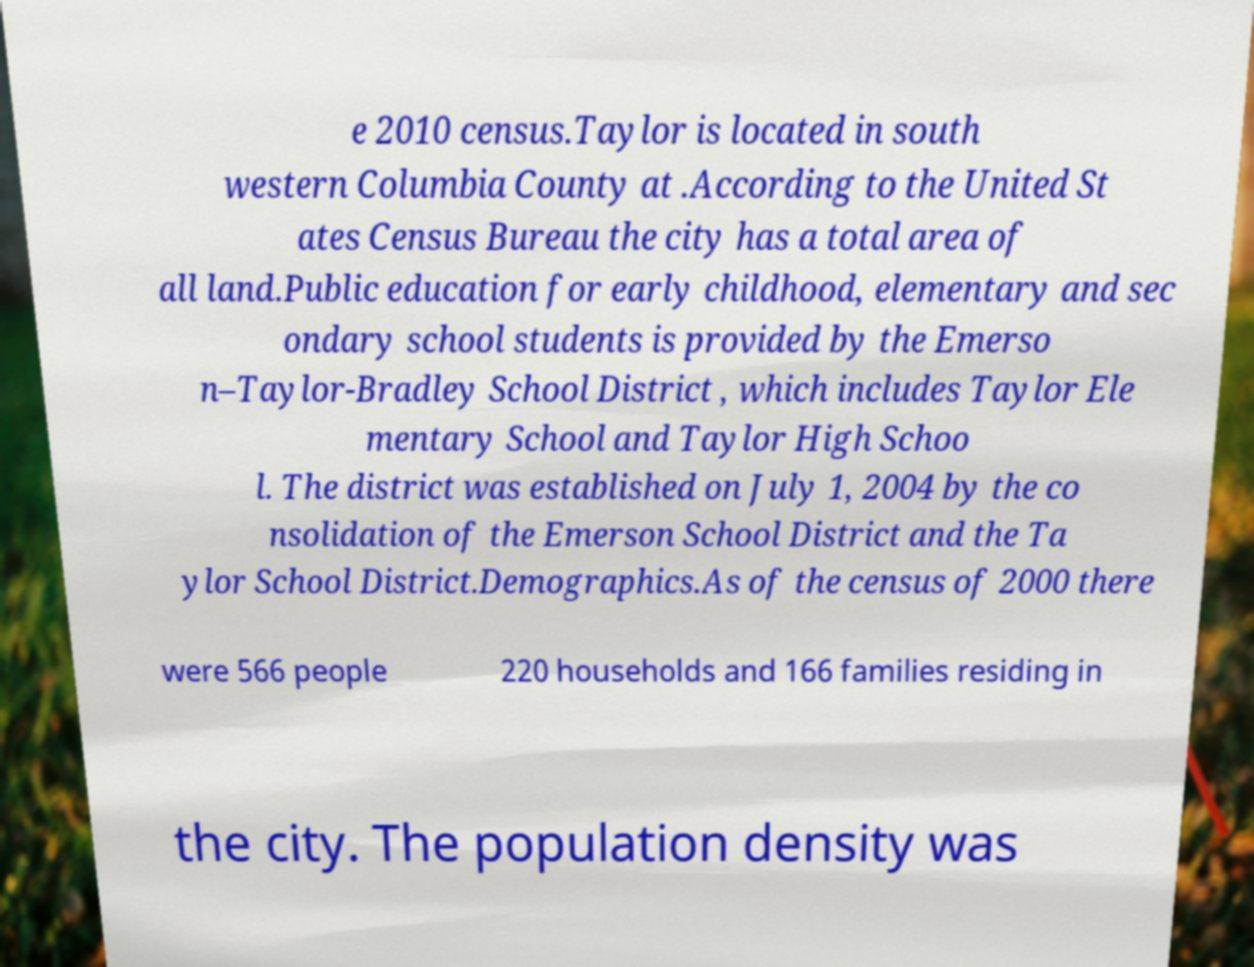Please identify and transcribe the text found in this image. e 2010 census.Taylor is located in south western Columbia County at .According to the United St ates Census Bureau the city has a total area of all land.Public education for early childhood, elementary and sec ondary school students is provided by the Emerso n–Taylor-Bradley School District , which includes Taylor Ele mentary School and Taylor High Schoo l. The district was established on July 1, 2004 by the co nsolidation of the Emerson School District and the Ta ylor School District.Demographics.As of the census of 2000 there were 566 people 220 households and 166 families residing in the city. The population density was 